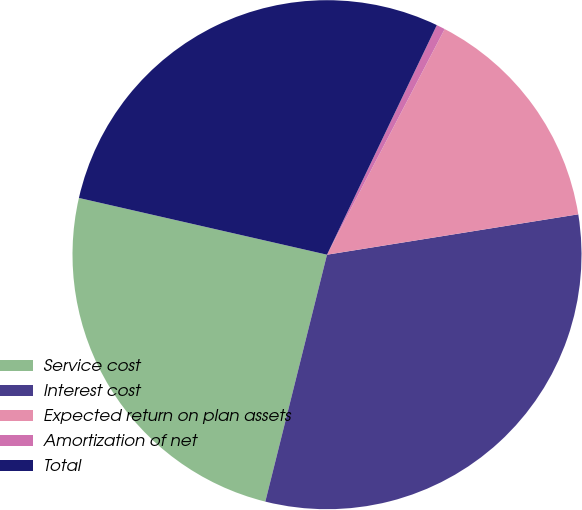<chart> <loc_0><loc_0><loc_500><loc_500><pie_chart><fcel>Service cost<fcel>Interest cost<fcel>Expected return on plan assets<fcel>Amortization of net<fcel>Total<nl><fcel>24.68%<fcel>31.43%<fcel>14.81%<fcel>0.55%<fcel>28.52%<nl></chart> 